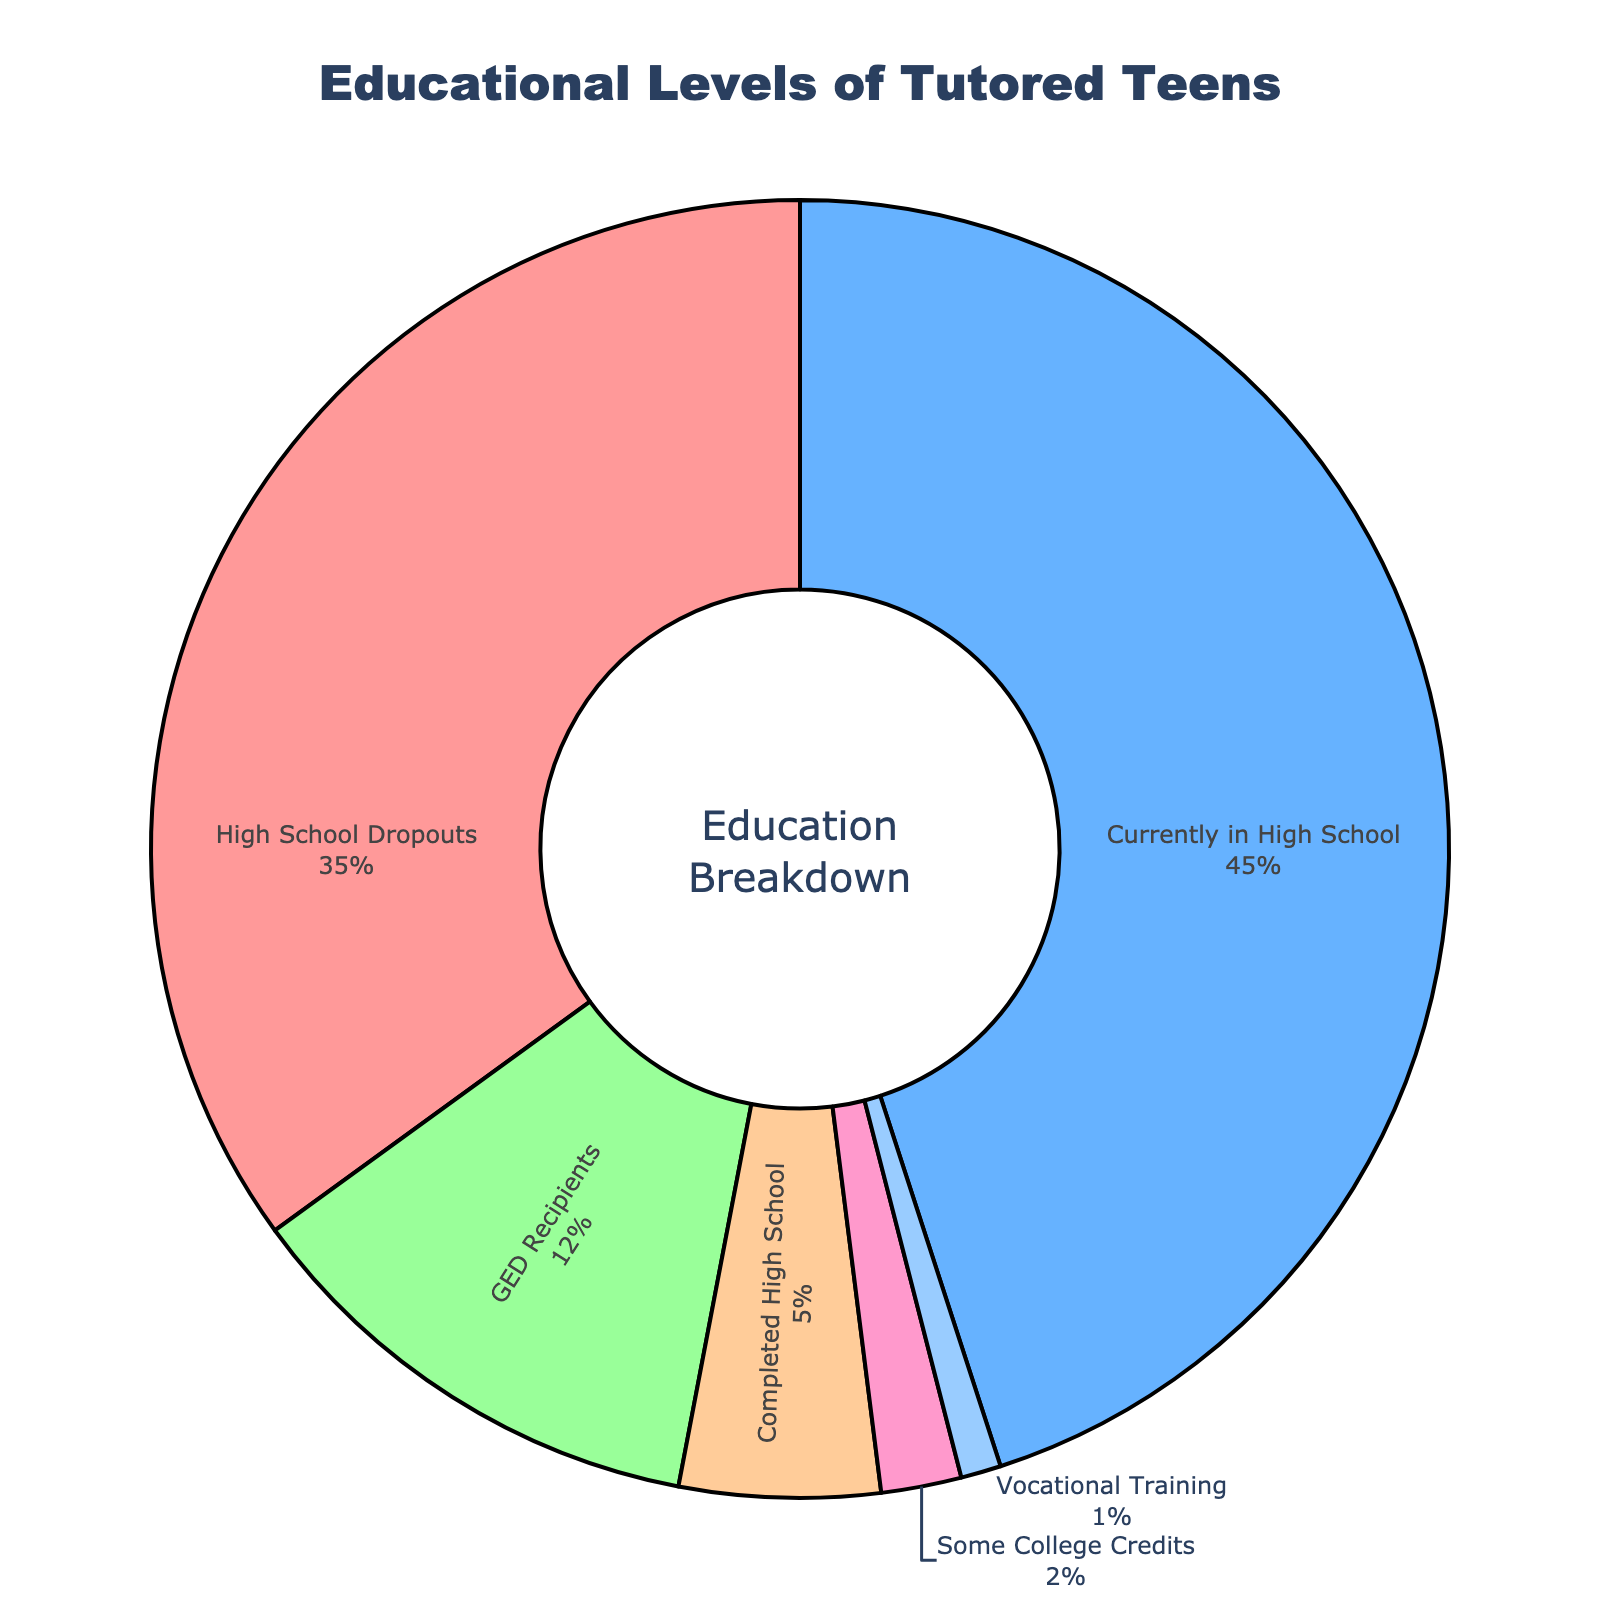What percentage of tutored teens are currently in high school? Looking at the pie chart, find the segment labeled "Currently in High School" and note its percentage value.
Answer: 45% What is the combined percentage of tutored teens who are high school dropouts or have a GED? Add the percentage of "High School Dropouts" (35%) to the percentage of "GED Recipients" (12%).
Answer: 47% Which educational level has the smallest group of tutored teens? Find the smallest segment in the pie chart. The segment labeled "Vocational Training" has the smallest percentage.
Answer: Vocational Training How many times more tutored teens are currently in high school compared to those with some college credits? Divide the percentage of "Currently in High School" (45%) by the percentage of "Some College Credits" (2%).
Answer: 22.5 times What is the difference in percentage between high school dropouts and those who have completed high school? Subtract the percentage of "Completed High School" (5%) from the percentage of "High School Dropouts" (35%).
Answer: 30% How does the percentage of GED recipients compare to the percentage of tutored teens in vocational training? Compare the percentage of "GED Recipients" (12%) with "Vocational Training" (1%). GED Recipients have a higher percentage.
Answer: GED Recipients have greater percentage What is the combined percentage of tutored teens who are either currently in high school or have completed some college credits? Add the percentage of "Currently in High School" (45%) to the percentage of "Some College Credits" (2%).
Answer: 47% If the total number of tutored teens is 100, how many teens have a GED? Since the percentage of "GED Recipients" is 12%, multiplying 12% by 100 gives the number of GED recipients.
Answer: 12 teens What percentage of tutored teens are neither high school dropouts nor currently in high school? Add up the percentages of all categories other than "High School Dropouts" (35%) and "Currently in High School" (45%), then subtract from 100. (1 + 2 + 12 + 5 = 20) Subtract from 100, i.e., 100 - 80.
Answer: 20% 